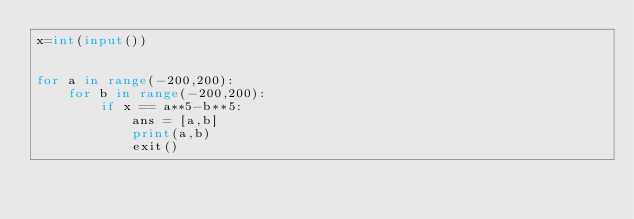Convert code to text. <code><loc_0><loc_0><loc_500><loc_500><_Python_>x=int(input())


for a in range(-200,200):
    for b in range(-200,200):
        if x == a**5-b**5:
            ans = [a,b]
            print(a,b)
            exit()
    </code> 